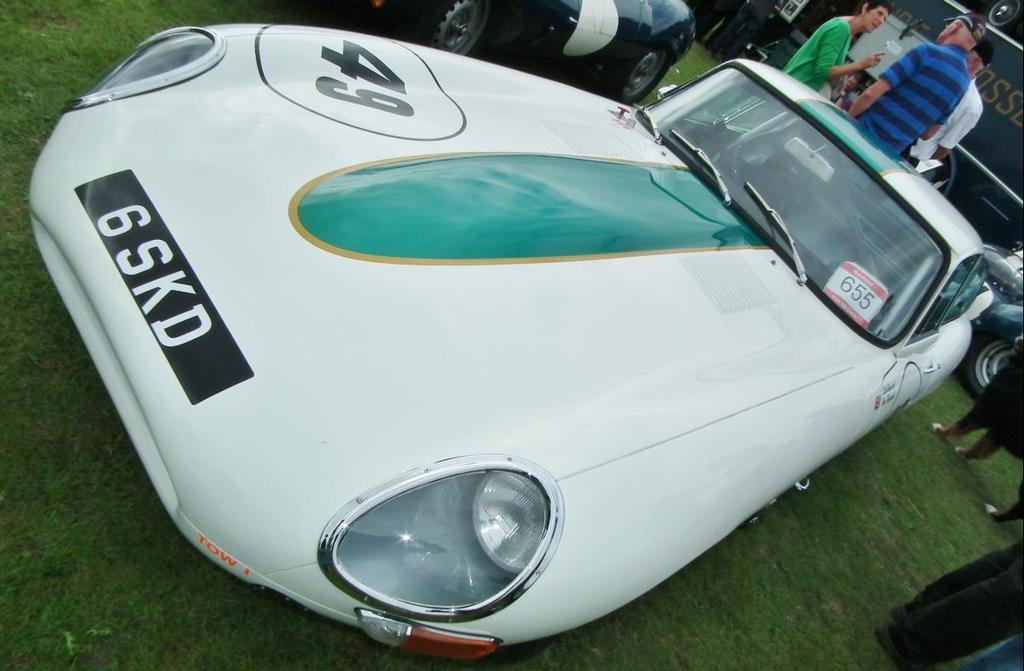What type of vehicles can be seen in the image? There are cars in the image. Can you describe the people in the image? There is a group of people in the image. What structure is visible in the image? There is a building in the image. What type of natural environment is present in the image? There is grass in the image. Where is the hook located in the image? There is no hook present in the image. What type of animal is sitting on the throne in the image? There is no throne or animal present in the image. 